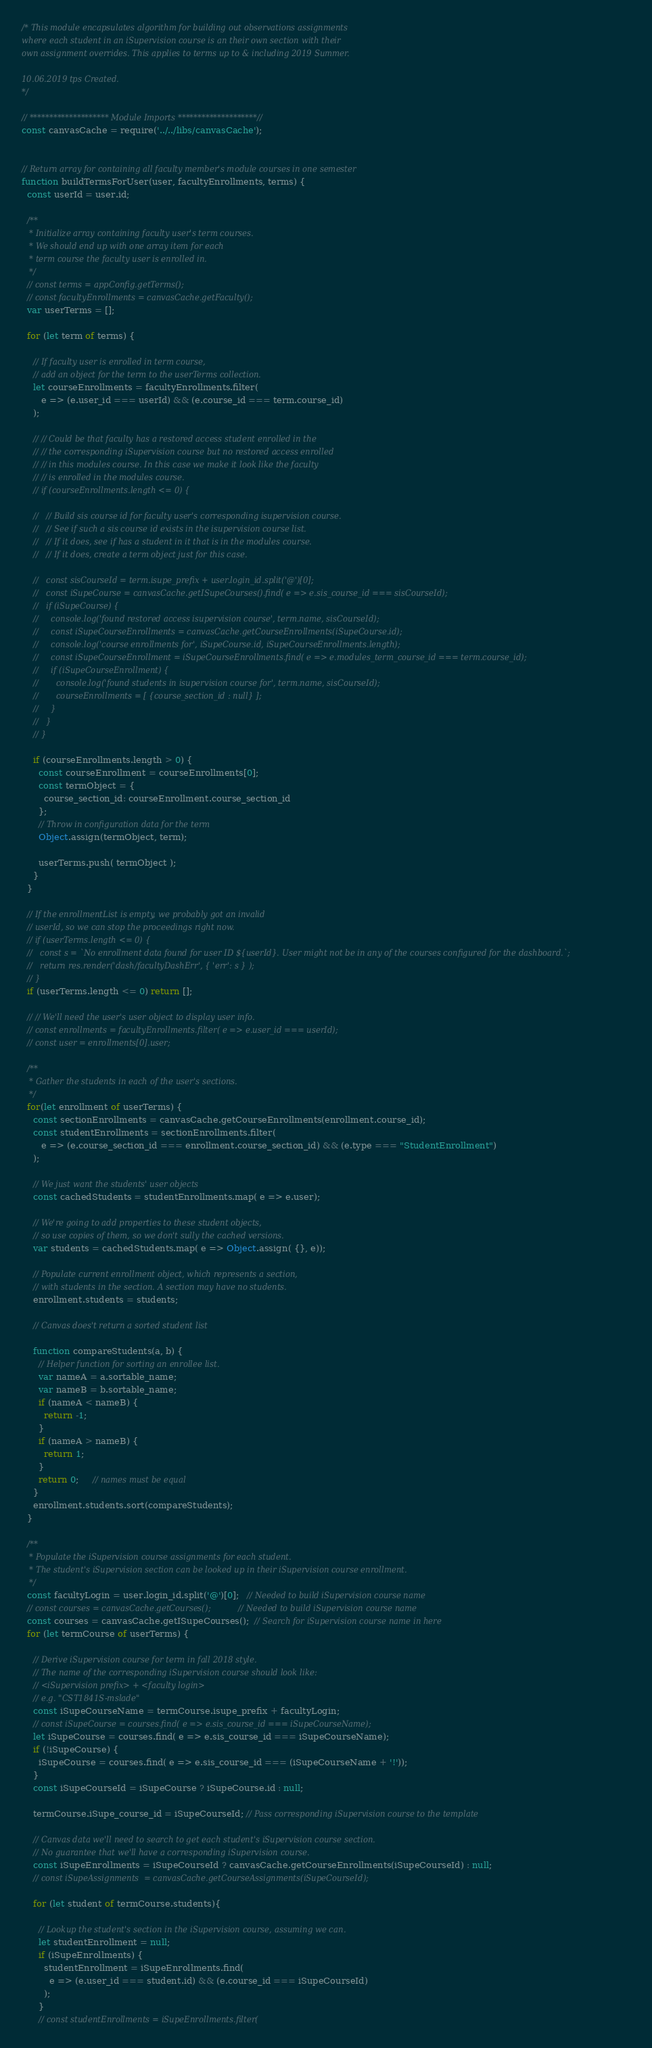<code> <loc_0><loc_0><loc_500><loc_500><_JavaScript_>/* This module encapsulates algorithm for building out observations assignments
where each student in an iSupervision course is an their own section with their
own assignment overrides. This applies to terms up to & including 2019 Summer.

10.06.2019 tps Created.
*/

// ******************** Module Imports ********************//
const canvasCache = require('../../libs/canvasCache');


// Return array for containing all faculty member's module courses in one semester
function buildTermsForUser(user, facultyEnrollments, terms) {
  const userId = user.id;

  /**
   * Initialize array containing faculty user's term courses.
   * We should end up with one array item for each
   * term course the faculty user is enrolled in.
   */
  // const terms = appConfig.getTerms();
  // const facultyEnrollments = canvasCache.getFaculty();
  var userTerms = [];

  for (let term of terms) {

    // If faculty user is enrolled in term course, 
    // add an object for the term to the userTerms collection.
    let courseEnrollments = facultyEnrollments.filter(
       e => (e.user_id === userId) && (e.course_id === term.course_id)
    );
    
    // // Could be that faculty has a restored access student enrolled in the
    // // the corresponding iSupervision course but no restored access enrolled 
    // // in this modules course. In this case we make it look like the faculty
    // // is enrolled in the modules course.
    // if (courseEnrollments.length <= 0) {

    //   // Build sis course id for faculty user's corresponding isupervision course.
    //   // See if such a sis course id exists in the isupervision course list.
    //   // If it does, see if has a student in it that is in the modules course.
    //   // If it does, create a term object just for this case.

    //   const sisCourseId = term.isupe_prefix + user.login_id.split('@')[0];
    //   const iSupeCourse = canvasCache.getISupeCourses().find( e => e.sis_course_id === sisCourseId);
    //   if (iSupeCourse) {
    //     console.log('found restored access isupervision course', term.name, sisCourseId);
    //     const iSupeCourseEnrollments = canvasCache.getCourseEnrollments(iSupeCourse.id);
    //     console.log('course enrollments for', iSupeCourse.id, iSupeCourseEnrollments.length);
    //     const iSupeCourseEnrollment = iSupeCourseEnrollments.find( e => e.modules_term_course_id === term.course_id);
    //     if (iSupeCourseEnrollment) {
    //       console.log('found students in isupervision course for', term.name, sisCourseId);
    //       courseEnrollments = [ {course_section_id : null} ];
    //     }
    //   }
    // }

    if (courseEnrollments.length > 0) {
      const courseEnrollment = courseEnrollments[0];
      const termObject = {
        course_section_id: courseEnrollment.course_section_id
      };
      // Throw in configuration data for the term
      Object.assign(termObject, term);

      userTerms.push( termObject );
    }
  }

  // If the enrollmentList is empty, we probably got an invalid
  // userId, so we can stop the proceedings right now.
  // if (userTerms.length <= 0) {
  //   const s = `No enrollment data found for user ID ${userId}. User might not be in any of the courses configured for the dashboard.`;
  //   return res.render('dash/facultyDashErr', { 'err': s } );
  // }
  if (userTerms.length <= 0) return [];

  // // We'll need the user's user object to display user info.
  // const enrollments = facultyEnrollments.filter( e => e.user_id === userId);
  // const user = enrollments[0].user;

  /**
   * Gather the students in each of the user's sections.
   */
  for(let enrollment of userTerms) {
    const sectionEnrollments = canvasCache.getCourseEnrollments(enrollment.course_id);
    const studentEnrollments = sectionEnrollments.filter(
       e => (e.course_section_id === enrollment.course_section_id) && (e.type === "StudentEnrollment")
    );
    
    // We just want the students' user objects
    const cachedStudents = studentEnrollments.map( e => e.user);

    // We're going to add properties to these student objects,
    // so use copies of them, so we don't sully the cached versions.
    var students = cachedStudents.map( e => Object.assign( {}, e));

    // Populate current enrollment object, which represents a section,
    // with students in the section. A section may have no students.
    enrollment.students = students;

    // Canvas does't return a sorted student list

    function compareStudents(a, b) {
      // Helper function for sorting an enrollee list.
      var nameA = a.sortable_name;
      var nameB = b.sortable_name;
      if (nameA < nameB) {
        return -1;
      }
      if (nameA > nameB) {
        return 1;
      }
      return 0;     // names must be equal
    }
    enrollment.students.sort(compareStudents);
  }
  
  /**
   * Populate the iSupervision course assignments for each student.
   * The student's iSupervision section can be looked up in their iSupervision course enrollment.
   */
  const facultyLogin = user.login_id.split('@')[0];   // Needed to build iSupervision course name
  // const courses = canvasCache.getCourses();           // Needed to build iSupervision course name
  const courses = canvasCache.getISupeCourses();  // Search for iSupervision course name in here
  for (let termCourse of userTerms) {

    // Derive iSupervision course for term in fall 2018 style.
    // The name of the corresponding iSupervision course should look like:
    // <iSupervision prefix> + <faculty login>
    // e.g. "CST1841S-mslade"    
    const iSupeCourseName = termCourse.isupe_prefix + facultyLogin;
    // const iSupeCourse = courses.find( e => e.sis_course_id === iSupeCourseName);
    let iSupeCourse = courses.find( e => e.sis_course_id === iSupeCourseName);
    if (!iSupeCourse) {
      iSupeCourse = courses.find( e => e.sis_course_id === (iSupeCourseName + '!'));
    }
    const iSupeCourseId = iSupeCourse ? iSupeCourse.id : null;

    termCourse.iSupe_course_id = iSupeCourseId; // Pass corresponding iSupervision course to the template

    // Canvas data we'll need to search to get each student's iSupervision course section.
    // No guarantee that we'll have a corresponding iSupervision course.
    const iSupeEnrollments = iSupeCourseId ? canvasCache.getCourseEnrollments(iSupeCourseId) : null;
    // const iSupeAssignments  = canvasCache.getCourseAssignments(iSupeCourseId);

    for (let student of termCourse.students){

      // Lookup the student's section in the iSupervision course, assuming we can.
      let studentEnrollment = null;
      if (iSupeEnrollments) {
        studentEnrollment = iSupeEnrollments.find(
          e => (e.user_id === student.id) && (e.course_id === iSupeCourseId)
        );
      }
      // const studentEnrollments = iSupeEnrollments.filter(</code> 